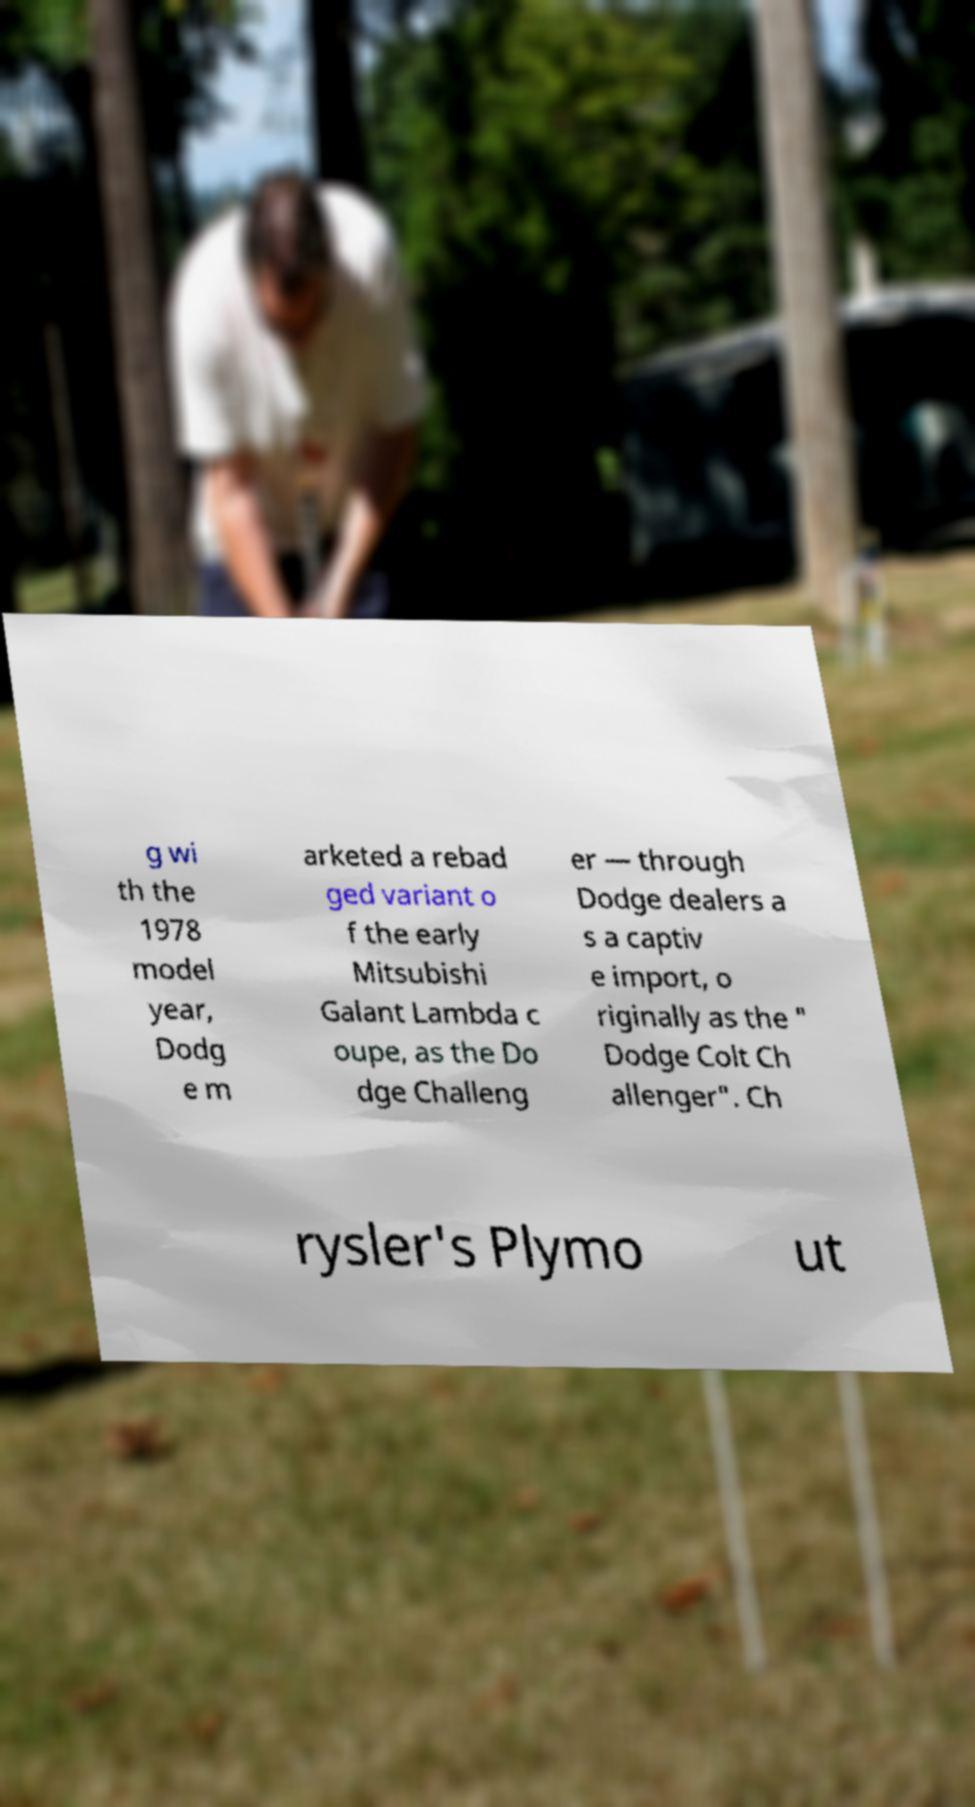Can you accurately transcribe the text from the provided image for me? g wi th the 1978 model year, Dodg e m arketed a rebad ged variant o f the early Mitsubishi Galant Lambda c oupe, as the Do dge Challeng er — through Dodge dealers a s a captiv e import, o riginally as the " Dodge Colt Ch allenger". Ch rysler's Plymo ut 